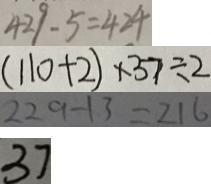<formula> <loc_0><loc_0><loc_500><loc_500>4 2 9 - 5 = 4 2 4 
 ( 1 1 0 + 2 ) \times 3 7 \div 2 
 2 2 9 - 1 3 = 2 1 6 
 3 7</formula> 